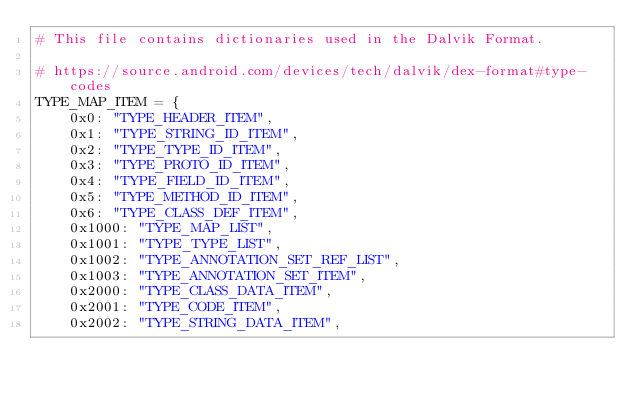Convert code to text. <code><loc_0><loc_0><loc_500><loc_500><_Python_># This file contains dictionaries used in the Dalvik Format.

# https://source.android.com/devices/tech/dalvik/dex-format#type-codes
TYPE_MAP_ITEM = {
    0x0: "TYPE_HEADER_ITEM",
    0x1: "TYPE_STRING_ID_ITEM",
    0x2: "TYPE_TYPE_ID_ITEM",
    0x3: "TYPE_PROTO_ID_ITEM",
    0x4: "TYPE_FIELD_ID_ITEM",
    0x5: "TYPE_METHOD_ID_ITEM",
    0x6: "TYPE_CLASS_DEF_ITEM",
    0x1000: "TYPE_MAP_LIST",
    0x1001: "TYPE_TYPE_LIST",
    0x1002: "TYPE_ANNOTATION_SET_REF_LIST",
    0x1003: "TYPE_ANNOTATION_SET_ITEM",
    0x2000: "TYPE_CLASS_DATA_ITEM",
    0x2001: "TYPE_CODE_ITEM",
    0x2002: "TYPE_STRING_DATA_ITEM",</code> 